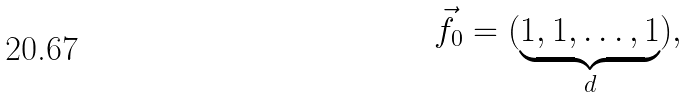<formula> <loc_0><loc_0><loc_500><loc_500>\vec { f _ { 0 } } = ( \underbrace { 1 , 1 , \dots , 1 } _ { d } ) ,</formula> 